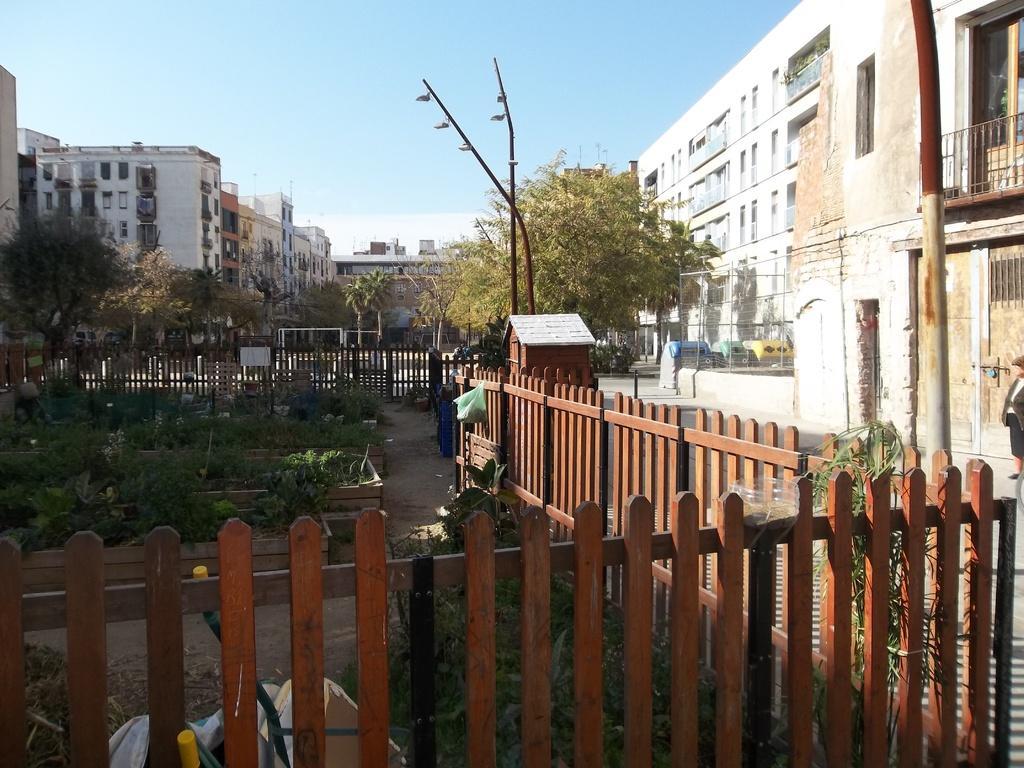Describe this image in one or two sentences. In this picture we can see fencing panel in the front, there are some plants and trees here, in the background there are buildings, we can see a person standing on the right side, there is the sky at the top of the picture. 